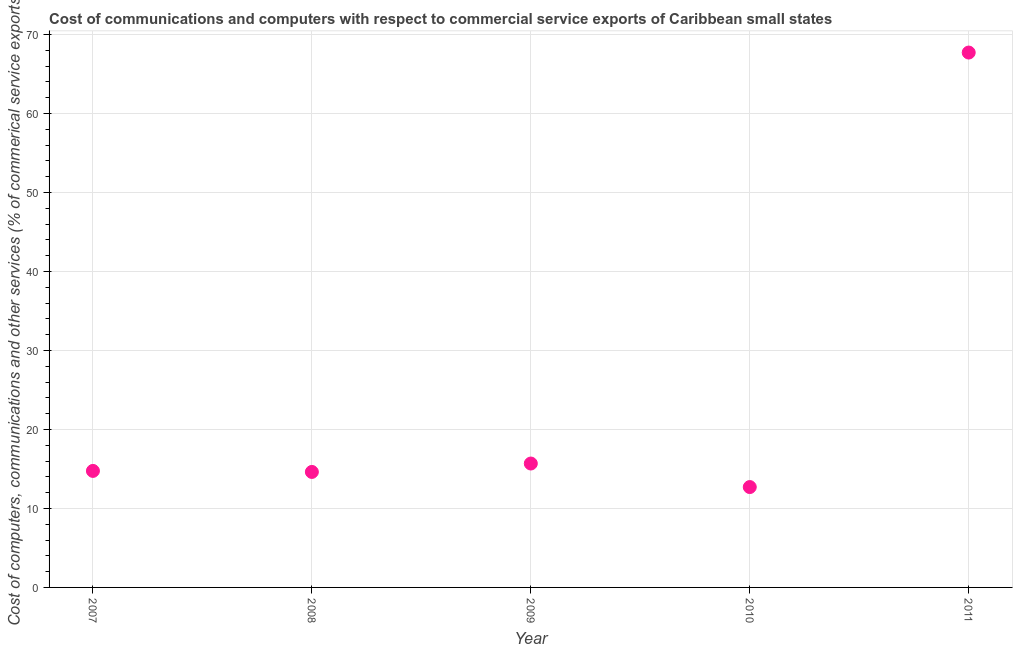What is the  computer and other services in 2008?
Your answer should be compact. 14.62. Across all years, what is the maximum cost of communications?
Provide a succinct answer. 67.71. Across all years, what is the minimum cost of communications?
Your answer should be compact. 12.7. What is the sum of the  computer and other services?
Your response must be concise. 125.46. What is the difference between the  computer and other services in 2009 and 2010?
Offer a terse response. 2.98. What is the average cost of communications per year?
Keep it short and to the point. 25.09. What is the median  computer and other services?
Offer a very short reply. 14.75. What is the ratio of the  computer and other services in 2009 to that in 2010?
Provide a succinct answer. 1.23. Is the  computer and other services in 2007 less than that in 2010?
Give a very brief answer. No. Is the difference between the cost of communications in 2008 and 2009 greater than the difference between any two years?
Keep it short and to the point. No. What is the difference between the highest and the second highest cost of communications?
Make the answer very short. 52.02. Is the sum of the  computer and other services in 2008 and 2009 greater than the maximum  computer and other services across all years?
Give a very brief answer. No. What is the difference between the highest and the lowest  computer and other services?
Offer a very short reply. 55. How many dotlines are there?
Your response must be concise. 1. How many years are there in the graph?
Offer a very short reply. 5. What is the difference between two consecutive major ticks on the Y-axis?
Ensure brevity in your answer.  10. Does the graph contain any zero values?
Keep it short and to the point. No. Does the graph contain grids?
Offer a very short reply. Yes. What is the title of the graph?
Offer a terse response. Cost of communications and computers with respect to commercial service exports of Caribbean small states. What is the label or title of the X-axis?
Provide a succinct answer. Year. What is the label or title of the Y-axis?
Ensure brevity in your answer.  Cost of computers, communications and other services (% of commerical service exports). What is the Cost of computers, communications and other services (% of commerical service exports) in 2007?
Make the answer very short. 14.75. What is the Cost of computers, communications and other services (% of commerical service exports) in 2008?
Your response must be concise. 14.62. What is the Cost of computers, communications and other services (% of commerical service exports) in 2009?
Your response must be concise. 15.68. What is the Cost of computers, communications and other services (% of commerical service exports) in 2010?
Offer a terse response. 12.7. What is the Cost of computers, communications and other services (% of commerical service exports) in 2011?
Offer a very short reply. 67.71. What is the difference between the Cost of computers, communications and other services (% of commerical service exports) in 2007 and 2008?
Offer a very short reply. 0.13. What is the difference between the Cost of computers, communications and other services (% of commerical service exports) in 2007 and 2009?
Provide a succinct answer. -0.94. What is the difference between the Cost of computers, communications and other services (% of commerical service exports) in 2007 and 2010?
Give a very brief answer. 2.04. What is the difference between the Cost of computers, communications and other services (% of commerical service exports) in 2007 and 2011?
Give a very brief answer. -52.96. What is the difference between the Cost of computers, communications and other services (% of commerical service exports) in 2008 and 2009?
Your answer should be very brief. -1.06. What is the difference between the Cost of computers, communications and other services (% of commerical service exports) in 2008 and 2010?
Provide a short and direct response. 1.91. What is the difference between the Cost of computers, communications and other services (% of commerical service exports) in 2008 and 2011?
Provide a succinct answer. -53.09. What is the difference between the Cost of computers, communications and other services (% of commerical service exports) in 2009 and 2010?
Your answer should be very brief. 2.98. What is the difference between the Cost of computers, communications and other services (% of commerical service exports) in 2009 and 2011?
Your answer should be compact. -52.02. What is the difference between the Cost of computers, communications and other services (% of commerical service exports) in 2010 and 2011?
Keep it short and to the point. -55. What is the ratio of the Cost of computers, communications and other services (% of commerical service exports) in 2007 to that in 2010?
Provide a succinct answer. 1.16. What is the ratio of the Cost of computers, communications and other services (% of commerical service exports) in 2007 to that in 2011?
Keep it short and to the point. 0.22. What is the ratio of the Cost of computers, communications and other services (% of commerical service exports) in 2008 to that in 2009?
Offer a terse response. 0.93. What is the ratio of the Cost of computers, communications and other services (% of commerical service exports) in 2008 to that in 2010?
Your answer should be very brief. 1.15. What is the ratio of the Cost of computers, communications and other services (% of commerical service exports) in 2008 to that in 2011?
Ensure brevity in your answer.  0.22. What is the ratio of the Cost of computers, communications and other services (% of commerical service exports) in 2009 to that in 2010?
Provide a succinct answer. 1.24. What is the ratio of the Cost of computers, communications and other services (% of commerical service exports) in 2009 to that in 2011?
Offer a terse response. 0.23. What is the ratio of the Cost of computers, communications and other services (% of commerical service exports) in 2010 to that in 2011?
Your answer should be very brief. 0.19. 